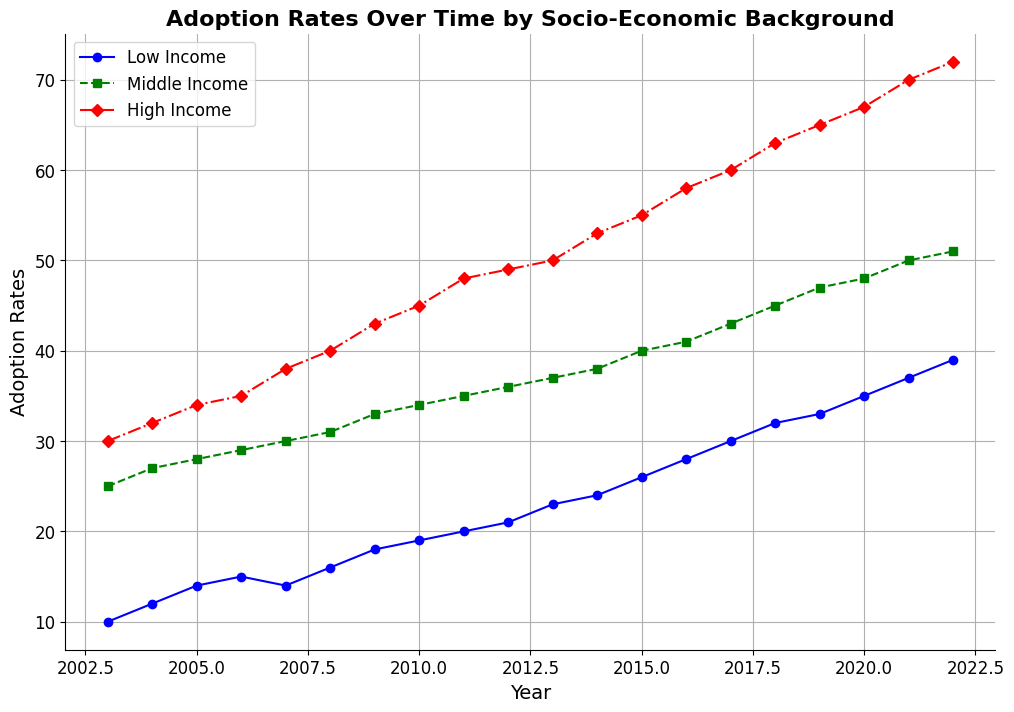Which socio-economic group had the highest adoption rate in 2022? By referring to the end of the lines in the chart for the year 2022, we can see the adoption rates. The highest line corresponds to the High Income group.
Answer: High Income How did the adoption rates for the Low Income group change between 2003 and 2022? Look at the starting and ending points of the Low Income line from 2003 to 2022. It starts at 10 in 2003 and ends at 39 in 2022. The increase is 39 - 10 = 29.
Answer: Increased by 29 Compare the adoption rate trends of the Middle Income and High Income groups. Which group had a larger increase over the last 20 years? The Middle Income group starts at 25 in 2003 and goes to 51 in 2022, an increase of 26. The High Income group starts at 30 in 2003 and goes to 72 in 2022, an increase of 42.
Answer: High Income Which socio-economic group had the most consistent increase in adoption rates over the 20-year period? By visually inspecting the smoothness and consistency of the lines, the Middle Income line appears to have the smoothest and most consistent upward trend without large fluctuations.
Answer: Middle Income What is the difference in adoption rates between Low Income and High Income groups in 2022? In 2022, the adoption rate for Low Income is 39 and for High Income is 72. The difference is 72 - 39 = 33.
Answer: 33 In which year did the Low Income group surpass a 20% adoption rate? By following the Low Income line, we see it surpasses the 20% mark between 2010 and 2011. In 2011, it reaches 20, so it surpasses 20% in 2012 when it reaches 21.
Answer: 2012 What was the adoption rate for the Middle Income group in 2018? By locating the point on the Middle Income line that corresponds to the year 2018, we see the adoption rate is 45.
Answer: 45 How much did the adoption rate for the High Income group increase from 2009 to 2015? The adoption rate for High Income in 2009 is 43 and in 2015 is 55. The increase is 55 - 43 = 12.
Answer: 12 Compare the slopes of the lines for Low Income and Middle Income groups between 2010 and 2015. Which group shows a steeper increase? From 2010 to 2015, the Low Income group's adoption rate goes from 19 to 26 (increase of 7), and the Middle Income group goes from 34 to 40 (increase of 6). The Low Income group has a steeper increase over these years.
Answer: Low Income Identify the year when the High Income group's adoption rate first reached 50. By following the High Income line, we see it reaches 50 in 2013.
Answer: 2013 